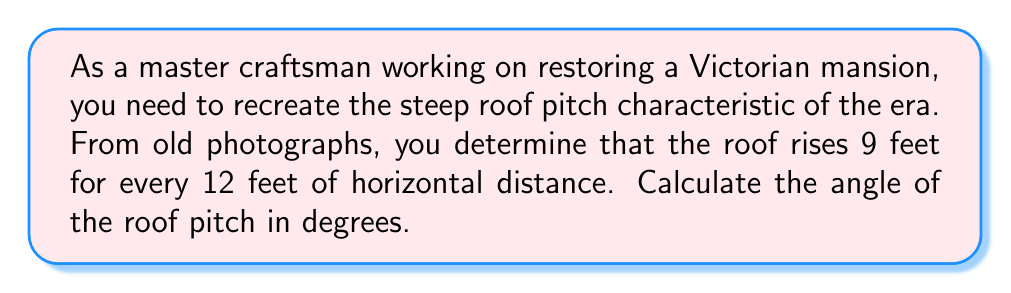Provide a solution to this math problem. To solve this problem, we'll use the tangent trigonometric ratio. Let's break it down step-by-step:

1. Identify the known values:
   - Rise (vertical distance) = 9 feet
   - Run (horizontal distance) = 12 feet

2. Recognize that these measurements form a right triangle, where:
   - The rise represents the opposite side
   - The run represents the adjacent side
   - The angle we're looking for is between the horizontal and the roof slope

3. Use the tangent ratio:
   $$ \tan(\theta) = \frac{\text{opposite}}{\text{adjacent}} = \frac{\text{rise}}{\text{run}} $$

4. Substitute the known values:
   $$ \tan(\theta) = \frac{9}{12} = \frac{3}{4} = 0.75 $$

5. To find the angle, we need to use the inverse tangent (arctangent) function:
   $$ \theta = \tan^{-1}(0.75) $$

6. Calculate the result:
   $$ \theta \approx 36.87^\circ $$

[asy]
import geometry;

size(200);
pair A=(0,0), B=(12,0), C=(0,9);
draw(A--B--C--A);
draw(A--(12,9),dashed);
label("9'",C--A,W);
label("12'",A--B,S);
label("$\theta$",A,NE);
markright(A,0.5);
[/asy]

The diagram above illustrates the roof pitch, with the angle θ that we calculated.
Answer: The angle of the Victorian roof's pitch is approximately 36.87°. 